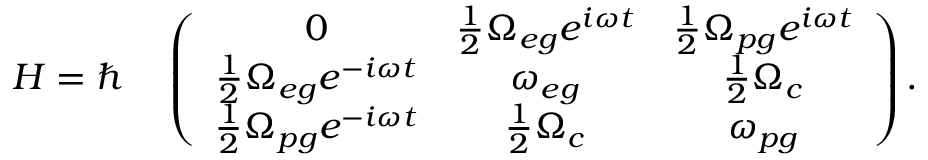Convert formula to latex. <formula><loc_0><loc_0><loc_500><loc_500>H = \hbar { \quad } \left ( \begin{array} { c c c } { 0 } & { \frac { 1 } { 2 } \Omega _ { e g } e ^ { i \omega t } } & { \frac { 1 } { 2 } \Omega _ { p g } e ^ { i \omega t } } \\ { \frac { 1 } { 2 } \Omega _ { e g } e ^ { - i \omega t } } & { \omega _ { e g } } & { \frac { 1 } { 2 } \Omega _ { c } } \\ { \frac { 1 } { 2 } \Omega _ { p g } e ^ { - i \omega t } } & { \frac { 1 } { 2 } \Omega _ { c } } & { \omega _ { p g } } \end{array} \right ) .</formula> 